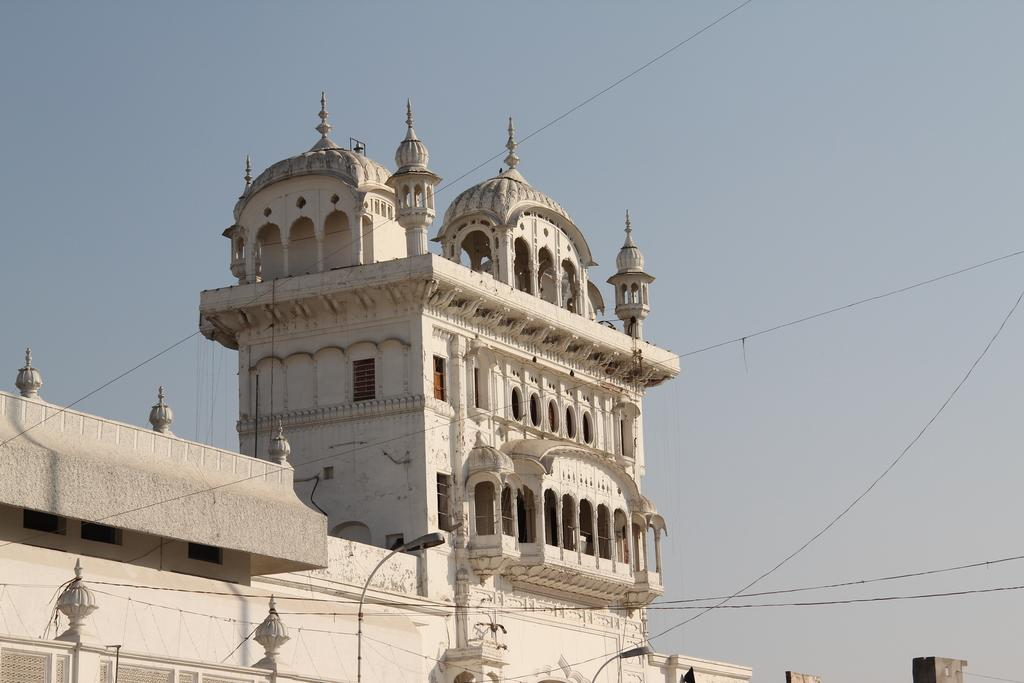What objects are located at the bottom of the image? There are lamps at the bottom of the image. What structure is in the middle of the image? There is a building in the middle of the image. What is visible at the top of the image? The sky is visible at the top of the image. Where is the stick located in the image? There is no stick present in the image. What type of mailbox can be seen near the building in the image? There is no mailbox present in the image. 